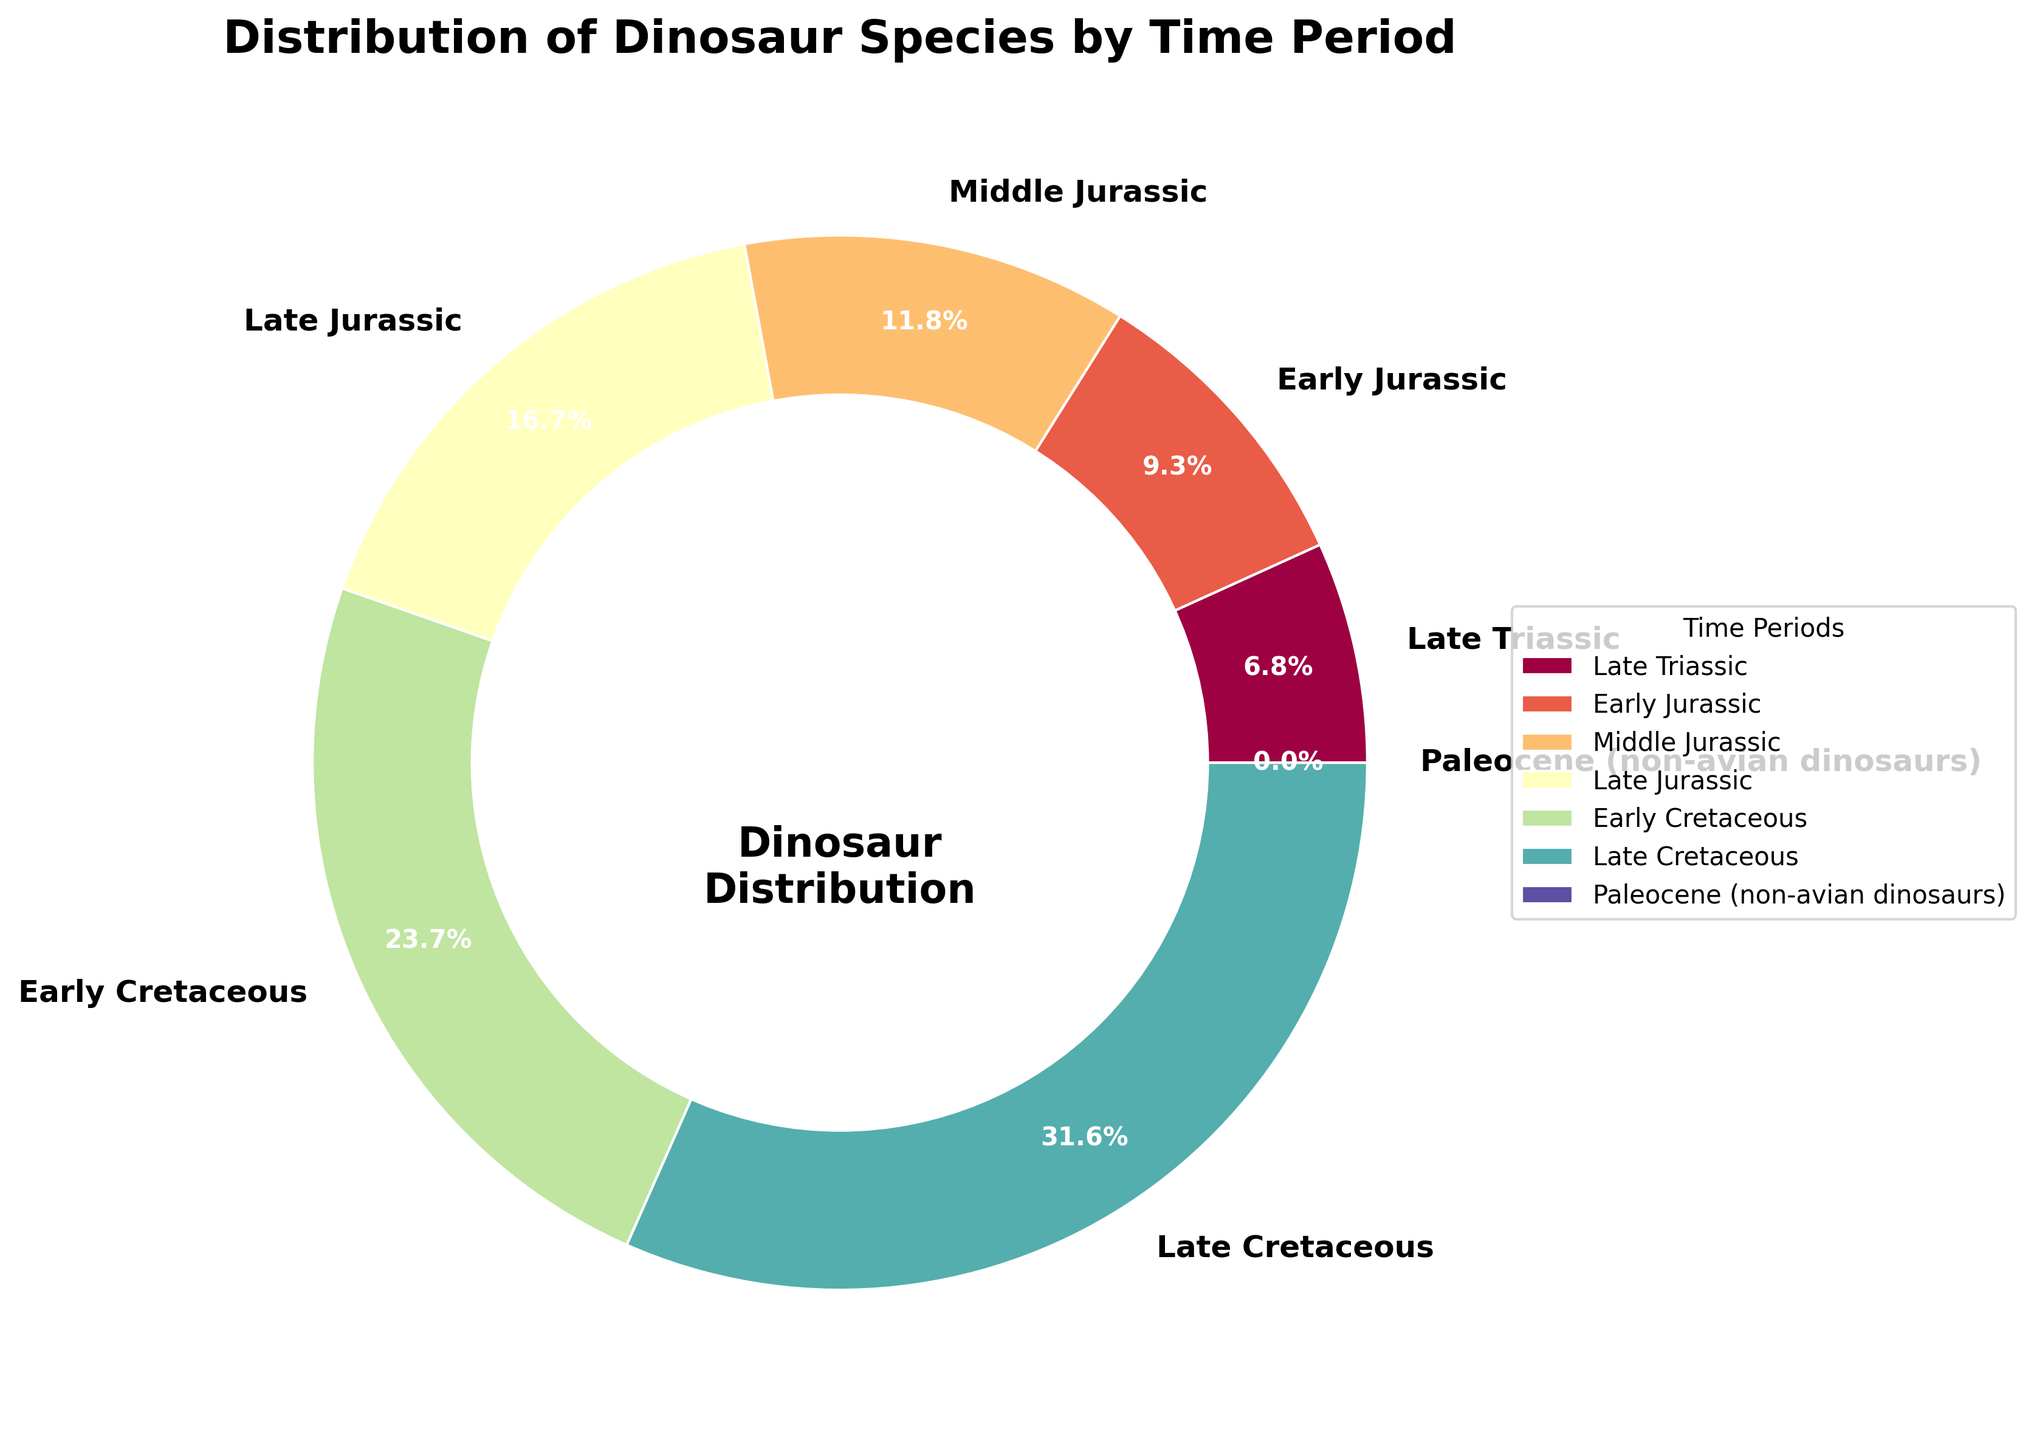What percentage of dinosaur species lived in the Late Cretaceous period? Look at the pie chart and find the segment labeled "Late Cretaceous." The percentage is displayed as part of the visual representation.
Answer: 37.6% Which time period had the fewest number of dinosaur species? Find the smallest segment on the pie chart and check the label.
Answer: Late Triassic Compare the number of dinosaur species in the Early Jurassic and Late Jurassic periods. Which period had more species? Identify the sections for Early Jurassic and Late Jurassic on the pie chart and compare the sizes or percentages labeled.
Answer: Late Jurassic By how many species does the Early Cretaceous period exceed the Middle Jurassic period? Identify the numeric values for both periods from the pie chart labels: Early Cretaceous has 217 species, Middle Jurassic has 108 species. Subtract 108 from 217.
Answer: 109 What fraction of the total dinosaur species did not live in the Paleocene period? Since the number of species in the Paleocene is 0, all species lived outside this period. The fraction is thus 100%.
Answer: 1 or 100% How does the number of species in the Middle Jurassic compare to the Late Triassic period? Using the pie chart, find the values for Middle Jurassic (108 species) and Late Triassic (62 species). Compare these values directly.
Answer: Middle Jurassic has 46 more species What is the combined percentage of dinosaur species living in the Late Jurassic and Early Cretaceous periods? According to the pie chart, Late Jurassic has 20.0% and Early Cretaceous has 28.3%. Add these percentages together (20.0 + 28.3 = 48.3%).
Answer: 48.3% What proportion of dinosaur species lived in the entire Jurassic period (Early, Middle, and Late Jurassic combined)? Sum the percentages for Early Jurassic (11.1%), Middle Jurassic (14.2%), and Late Jurassic (20.1%) from the pie chart. The total is 11.1 + 14.2 + 20.1 = 45.4%.
Answer: 45.4% Color-wise, which time period is represented by the central segment of the pie chart in the color closest to green? Observe the colors on the pie chart and find the segment closest to green. The middle segment closest to green is likely matched on the palette used.
Answer: Early Cretaceous 